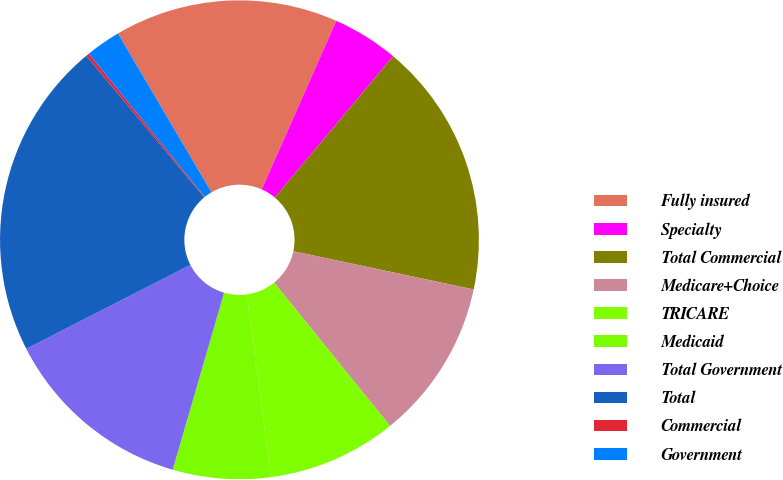<chart> <loc_0><loc_0><loc_500><loc_500><pie_chart><fcel>Fully insured<fcel>Specialty<fcel>Total Commercial<fcel>Medicare+Choice<fcel>TRICARE<fcel>Medicaid<fcel>Total Government<fcel>Total<fcel>Commercial<fcel>Government<nl><fcel>15.1%<fcel>4.47%<fcel>17.23%<fcel>10.85%<fcel>8.72%<fcel>6.6%<fcel>12.98%<fcel>21.48%<fcel>0.22%<fcel>2.35%<nl></chart> 